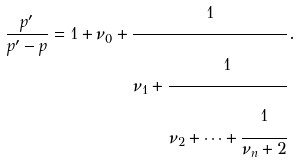Convert formula to latex. <formula><loc_0><loc_0><loc_500><loc_500>\frac { p ^ { \prime } } { p ^ { \prime } - p } = 1 + \nu _ { 0 } + \cfrac { 1 } { \nu _ { 1 } + \cfrac { 1 } { \nu _ { 2 } + \cdots + \cfrac { 1 } { \nu _ { n } + 2 } } } \, .</formula> 